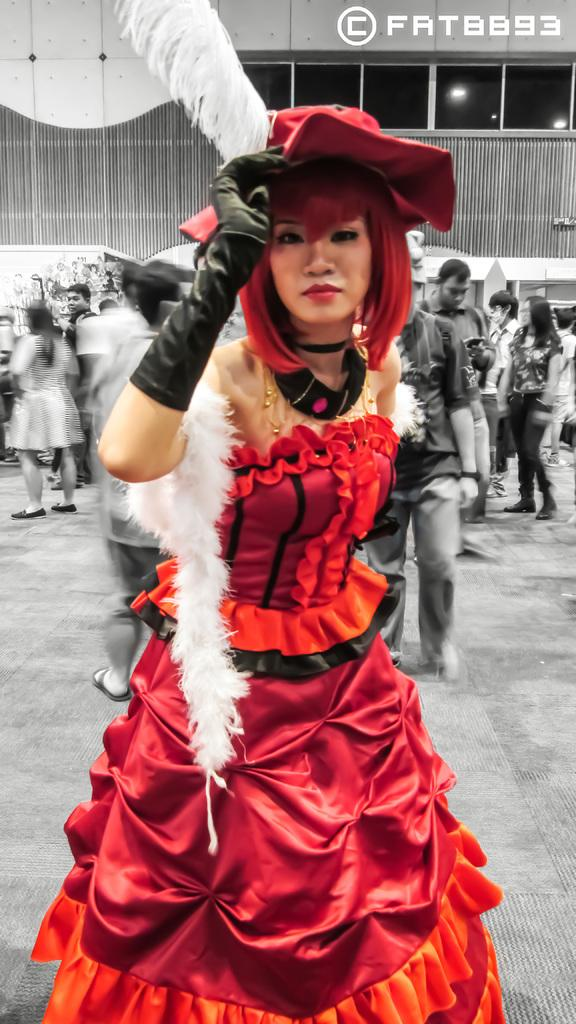What are the people in the image doing? The people in the image are walking on the ground. What can be seen in the background of the image? There is a building in the background of the image. What features does the building have? The building has a fence and a window. What is the temperature of the ice in the image? There is no ice present in the image. 